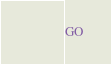Convert code to text. <code><loc_0><loc_0><loc_500><loc_500><_SQL_>GO
</code> 